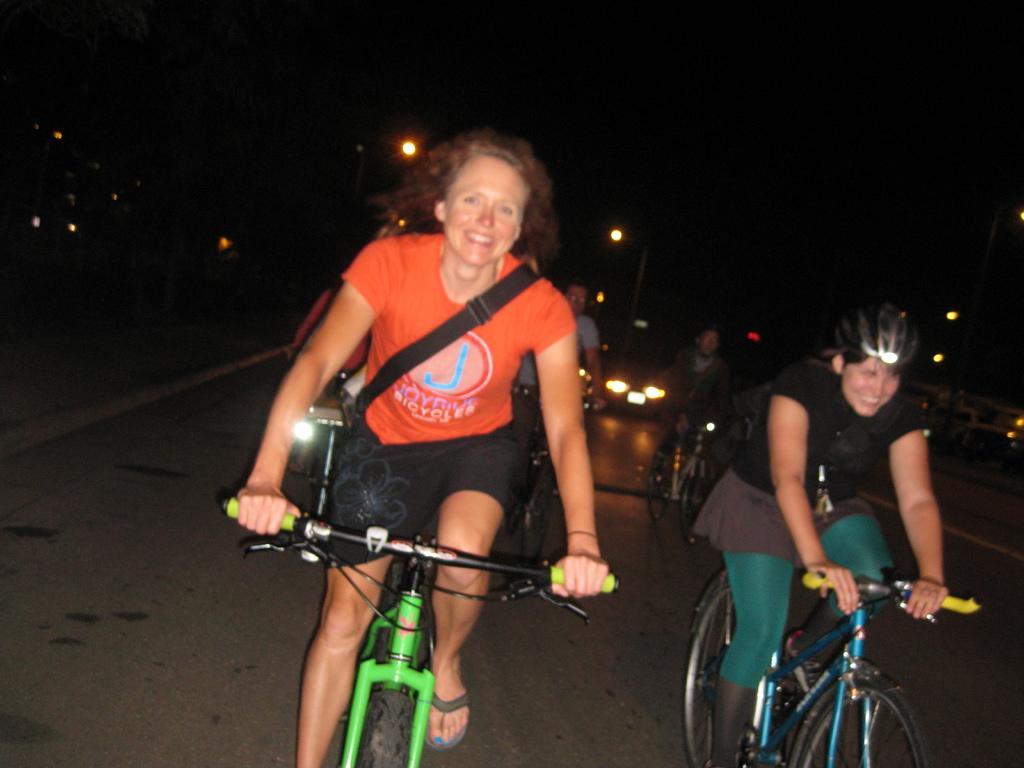Please provide a concise description of this image. This picture shows five people riding bicycles on the road and we see few vehicles moving on the back 